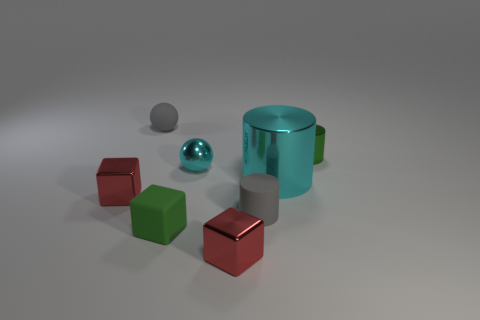Subtract all small gray rubber cylinders. How many cylinders are left? 2 Subtract all yellow cylinders. How many red cubes are left? 2 Add 1 tiny green rubber things. How many objects exist? 9 Subtract all spheres. How many objects are left? 6 Subtract all gray spheres. How many spheres are left? 1 Subtract all cyan metallic things. Subtract all large gray shiny cubes. How many objects are left? 6 Add 8 cyan metallic balls. How many cyan metallic balls are left? 9 Add 3 cyan cylinders. How many cyan cylinders exist? 4 Subtract 0 green balls. How many objects are left? 8 Subtract all purple cubes. Subtract all yellow cylinders. How many cubes are left? 3 